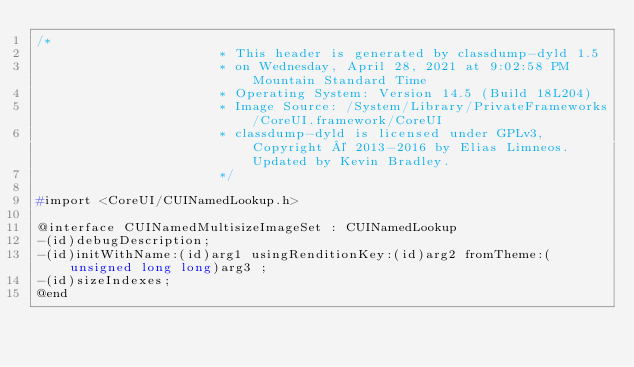<code> <loc_0><loc_0><loc_500><loc_500><_C_>/*
                       * This header is generated by classdump-dyld 1.5
                       * on Wednesday, April 28, 2021 at 9:02:58 PM Mountain Standard Time
                       * Operating System: Version 14.5 (Build 18L204)
                       * Image Source: /System/Library/PrivateFrameworks/CoreUI.framework/CoreUI
                       * classdump-dyld is licensed under GPLv3, Copyright © 2013-2016 by Elias Limneos. Updated by Kevin Bradley.
                       */

#import <CoreUI/CUINamedLookup.h>

@interface CUINamedMultisizeImageSet : CUINamedLookup
-(id)debugDescription;
-(id)initWithName:(id)arg1 usingRenditionKey:(id)arg2 fromTheme:(unsigned long long)arg3 ;
-(id)sizeIndexes;
@end

</code> 